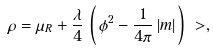<formula> <loc_0><loc_0><loc_500><loc_500>\rho & = \mu _ { R } + \frac { \lambda } { 4 } \, \left ( \, \phi ^ { 2 } - \frac { 1 } { 4 \pi } \, | m | \, \right ) \ > ,</formula> 